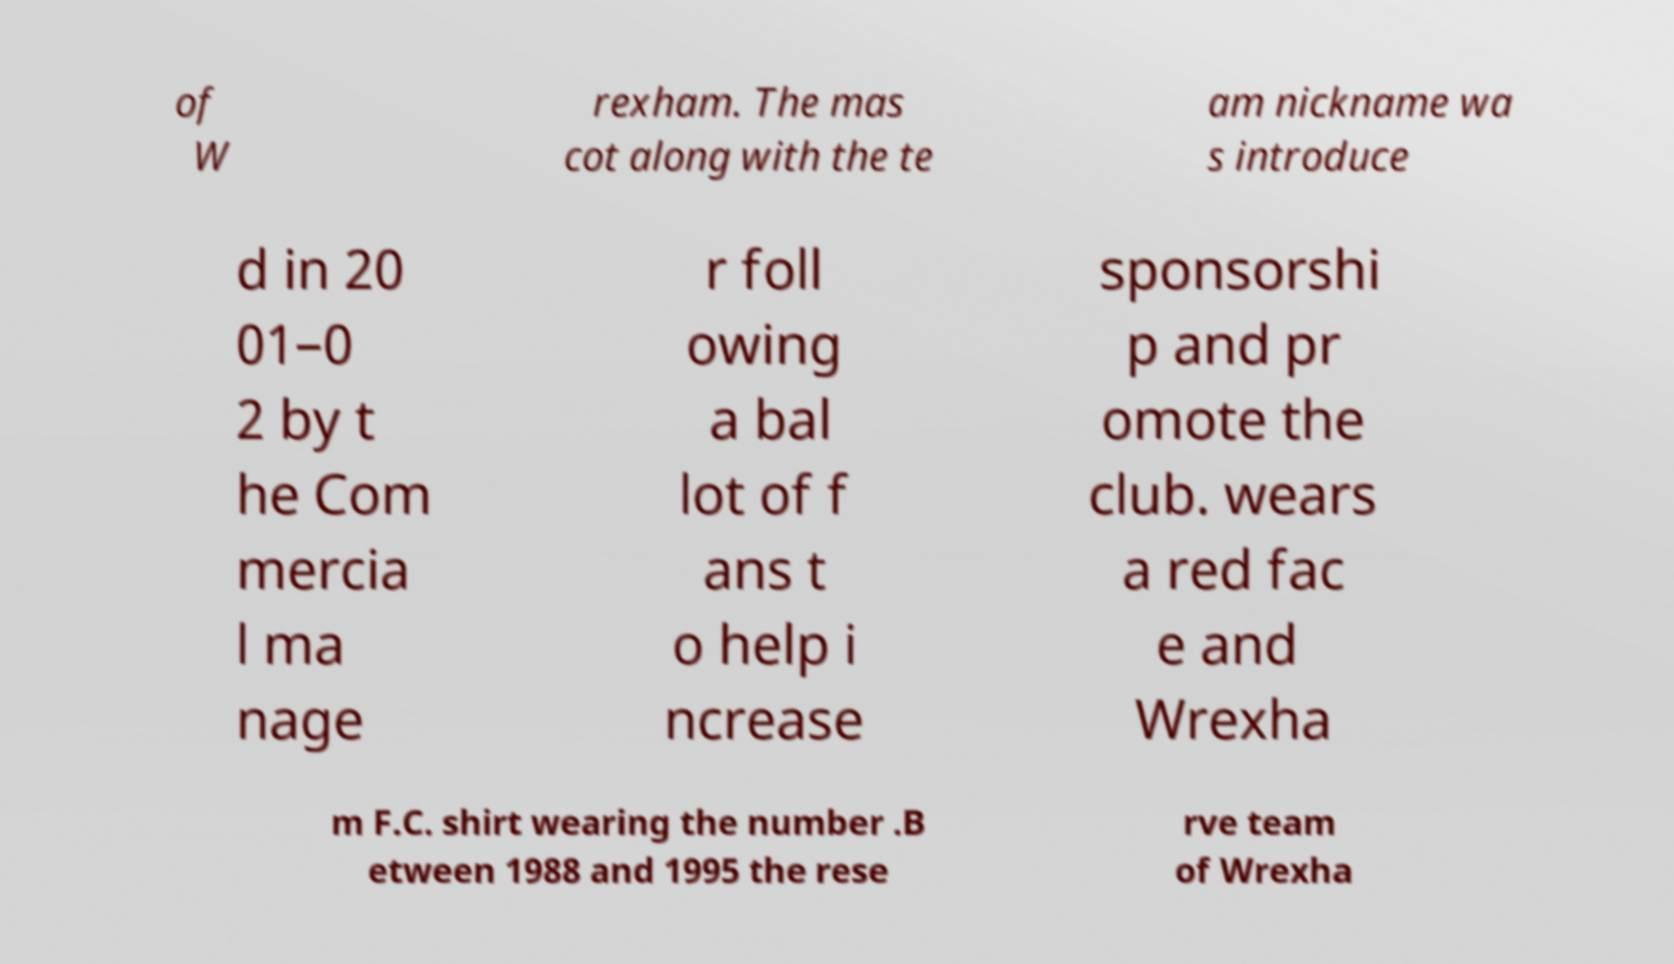I need the written content from this picture converted into text. Can you do that? of W rexham. The mas cot along with the te am nickname wa s introduce d in 20 01–0 2 by t he Com mercia l ma nage r foll owing a bal lot of f ans t o help i ncrease sponsorshi p and pr omote the club. wears a red fac e and Wrexha m F.C. shirt wearing the number .B etween 1988 and 1995 the rese rve team of Wrexha 